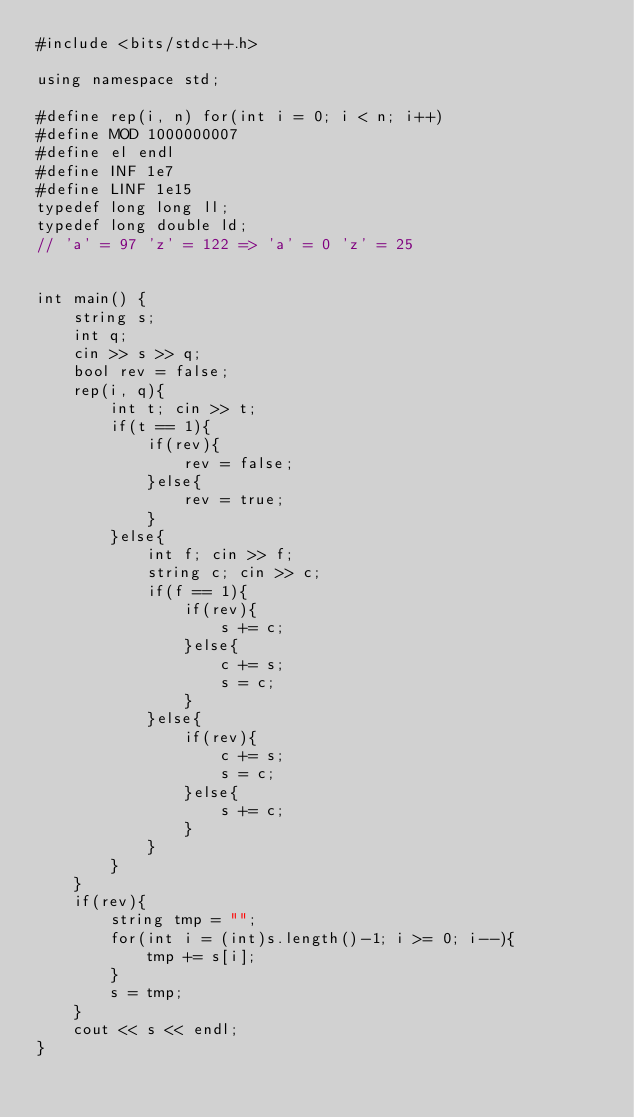<code> <loc_0><loc_0><loc_500><loc_500><_C++_>#include <bits/stdc++.h>

using namespace std;

#define rep(i, n) for(int i = 0; i < n; i++)
#define MOD 1000000007
#define el endl
#define INF 1e7
#define LINF 1e15
typedef long long ll;
typedef long double ld;
// 'a' = 97 'z' = 122 => 'a' = 0 'z' = 25


int main() {
    string s;
    int q;
    cin >> s >> q;
    bool rev = false;
    rep(i, q){
        int t; cin >> t;
        if(t == 1){
            if(rev){
                rev = false;
            }else{
                rev = true;
            }
        }else{
            int f; cin >> f;
            string c; cin >> c;
            if(f == 1){
                if(rev){
                    s += c;
                }else{
                    c += s;
                    s = c;
                }
            }else{
                if(rev){
                    c += s;
                    s = c;
                }else{
                    s += c;
                }
            }
        }
    }
    if(rev){
        string tmp = "";
        for(int i = (int)s.length()-1; i >= 0; i--){
            tmp += s[i];
        }
        s = tmp;
    }
    cout << s << endl;
}


</code> 